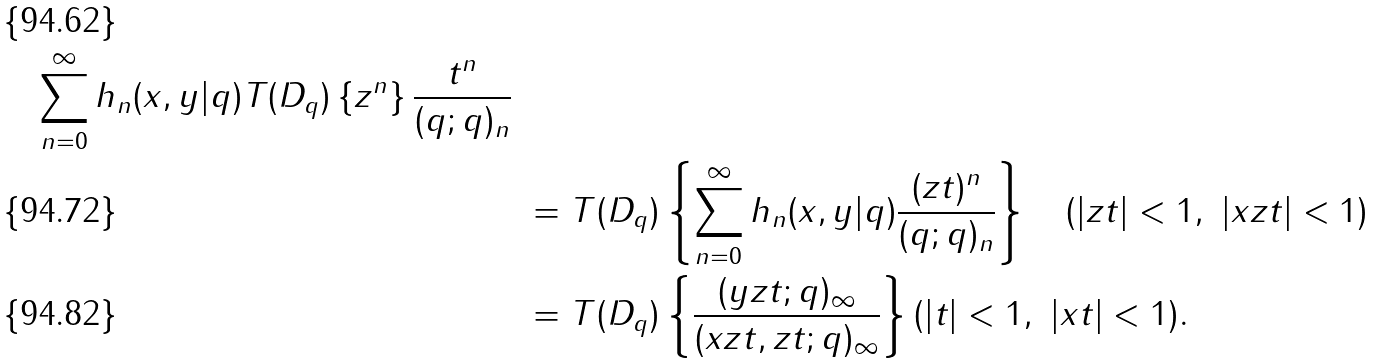Convert formula to latex. <formula><loc_0><loc_0><loc_500><loc_500>{ \sum _ { n = 0 } ^ { \infty } h _ { n } ( x , y | q ) T ( D _ { q } ) \left \{ z ^ { n } \right \} \frac { t ^ { n } } { ( q ; q ) _ { n } } } \\ & \ = T ( D _ { q } ) \left \{ \sum _ { n = 0 } ^ { \infty } h _ { n } ( x , y | q ) \frac { ( z t ) ^ { n } } { ( q ; q ) _ { n } } \right \} \quad ( | z t | < 1 , \ | x z t | < 1 ) \\ & \ = T ( D _ { q } ) \left \{ \frac { ( y z t ; q ) _ { \infty } } { ( x z t , z t ; q ) _ { \infty } } \right \} ( | t | < 1 , \ | x t | < 1 ) .</formula> 